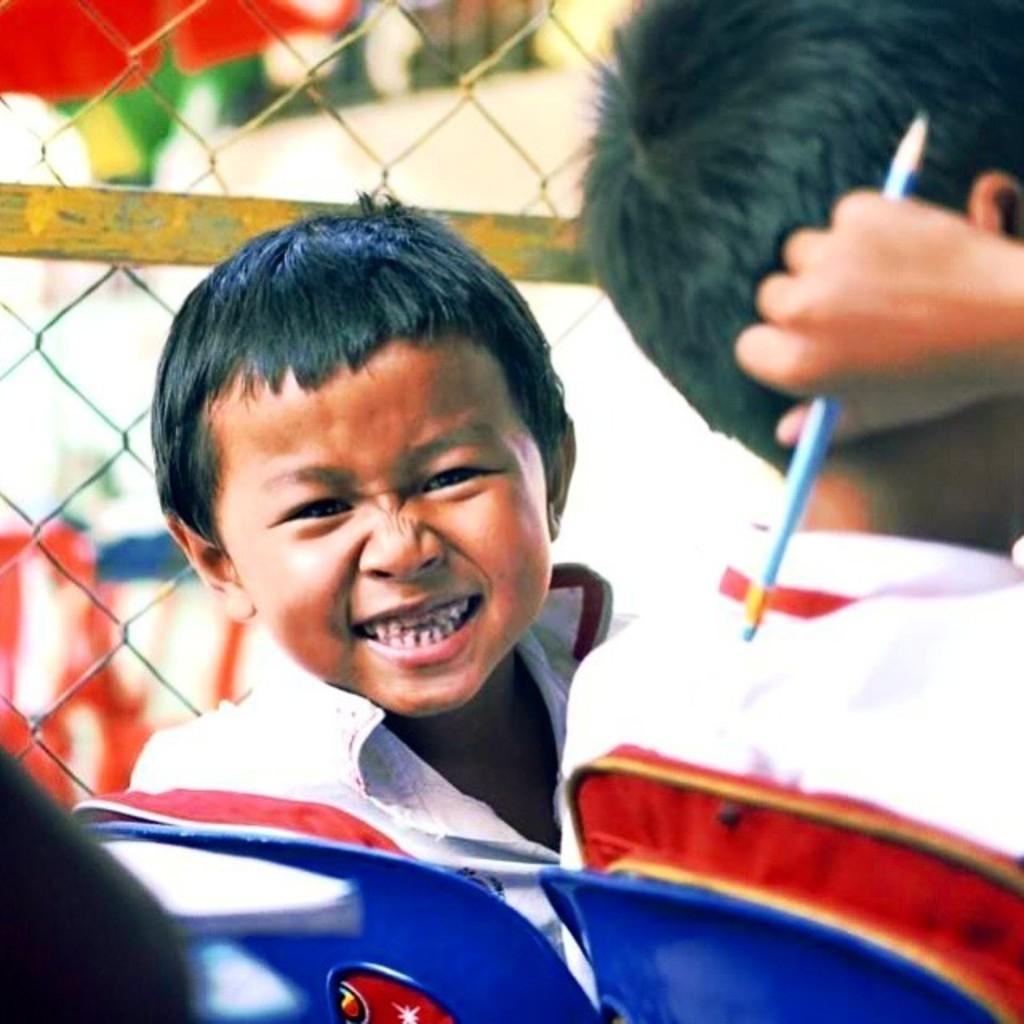Can you describe this image briefly? In this image there are two children sitting on the chairs, one of them is holding a pencil, behind them there is a net fencing. 